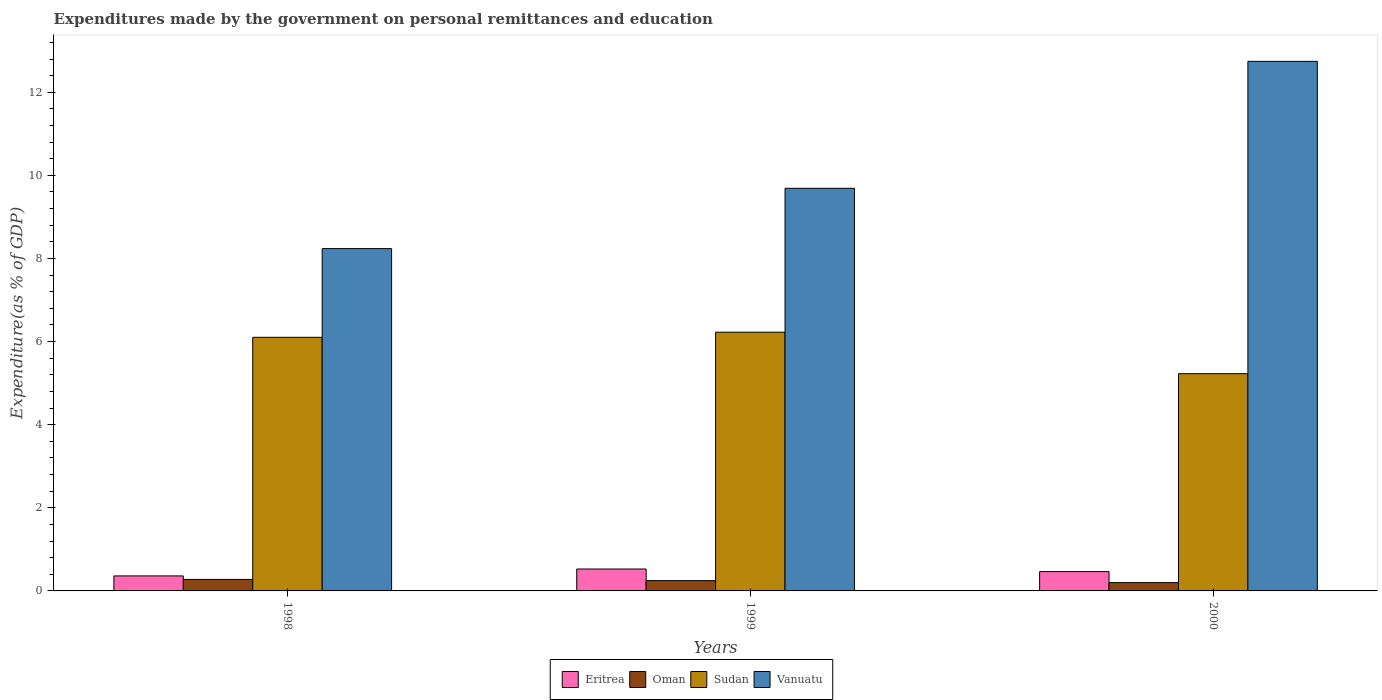How many different coloured bars are there?
Give a very brief answer. 4. Are the number of bars per tick equal to the number of legend labels?
Provide a short and direct response. Yes. Are the number of bars on each tick of the X-axis equal?
Provide a succinct answer. Yes. How many bars are there on the 2nd tick from the left?
Ensure brevity in your answer.  4. What is the label of the 2nd group of bars from the left?
Give a very brief answer. 1999. What is the expenditures made by the government on personal remittances and education in Vanuatu in 1999?
Your answer should be compact. 9.69. Across all years, what is the maximum expenditures made by the government on personal remittances and education in Oman?
Your response must be concise. 0.28. Across all years, what is the minimum expenditures made by the government on personal remittances and education in Oman?
Give a very brief answer. 0.2. In which year was the expenditures made by the government on personal remittances and education in Oman minimum?
Offer a very short reply. 2000. What is the total expenditures made by the government on personal remittances and education in Vanuatu in the graph?
Provide a short and direct response. 30.67. What is the difference between the expenditures made by the government on personal remittances and education in Oman in 1998 and that in 1999?
Ensure brevity in your answer.  0.03. What is the difference between the expenditures made by the government on personal remittances and education in Eritrea in 2000 and the expenditures made by the government on personal remittances and education in Oman in 1999?
Make the answer very short. 0.22. What is the average expenditures made by the government on personal remittances and education in Eritrea per year?
Your answer should be very brief. 0.45. In the year 1998, what is the difference between the expenditures made by the government on personal remittances and education in Eritrea and expenditures made by the government on personal remittances and education in Sudan?
Keep it short and to the point. -5.74. In how many years, is the expenditures made by the government on personal remittances and education in Eritrea greater than 8.4 %?
Provide a short and direct response. 0. What is the ratio of the expenditures made by the government on personal remittances and education in Vanuatu in 1998 to that in 2000?
Offer a very short reply. 0.65. Is the expenditures made by the government on personal remittances and education in Sudan in 1998 less than that in 2000?
Your answer should be very brief. No. Is the difference between the expenditures made by the government on personal remittances and education in Eritrea in 1998 and 2000 greater than the difference between the expenditures made by the government on personal remittances and education in Sudan in 1998 and 2000?
Make the answer very short. No. What is the difference between the highest and the second highest expenditures made by the government on personal remittances and education in Vanuatu?
Ensure brevity in your answer.  3.05. What is the difference between the highest and the lowest expenditures made by the government on personal remittances and education in Oman?
Keep it short and to the point. 0.08. In how many years, is the expenditures made by the government on personal remittances and education in Sudan greater than the average expenditures made by the government on personal remittances and education in Sudan taken over all years?
Your response must be concise. 2. Is the sum of the expenditures made by the government on personal remittances and education in Oman in 1999 and 2000 greater than the maximum expenditures made by the government on personal remittances and education in Eritrea across all years?
Your response must be concise. No. Is it the case that in every year, the sum of the expenditures made by the government on personal remittances and education in Sudan and expenditures made by the government on personal remittances and education in Oman is greater than the sum of expenditures made by the government on personal remittances and education in Vanuatu and expenditures made by the government on personal remittances and education in Eritrea?
Give a very brief answer. No. What does the 1st bar from the left in 1999 represents?
Provide a succinct answer. Eritrea. What does the 4th bar from the right in 1999 represents?
Give a very brief answer. Eritrea. Is it the case that in every year, the sum of the expenditures made by the government on personal remittances and education in Vanuatu and expenditures made by the government on personal remittances and education in Sudan is greater than the expenditures made by the government on personal remittances and education in Eritrea?
Offer a terse response. Yes. Are all the bars in the graph horizontal?
Ensure brevity in your answer.  No. How many years are there in the graph?
Provide a short and direct response. 3. Are the values on the major ticks of Y-axis written in scientific E-notation?
Your response must be concise. No. Where does the legend appear in the graph?
Offer a terse response. Bottom center. How many legend labels are there?
Keep it short and to the point. 4. How are the legend labels stacked?
Provide a succinct answer. Horizontal. What is the title of the graph?
Keep it short and to the point. Expenditures made by the government on personal remittances and education. Does "Bahrain" appear as one of the legend labels in the graph?
Your answer should be very brief. No. What is the label or title of the X-axis?
Provide a short and direct response. Years. What is the label or title of the Y-axis?
Offer a terse response. Expenditure(as % of GDP). What is the Expenditure(as % of GDP) in Eritrea in 1998?
Make the answer very short. 0.36. What is the Expenditure(as % of GDP) of Oman in 1998?
Your answer should be very brief. 0.28. What is the Expenditure(as % of GDP) of Sudan in 1998?
Give a very brief answer. 6.1. What is the Expenditure(as % of GDP) of Vanuatu in 1998?
Ensure brevity in your answer.  8.24. What is the Expenditure(as % of GDP) in Eritrea in 1999?
Your answer should be compact. 0.53. What is the Expenditure(as % of GDP) of Oman in 1999?
Offer a very short reply. 0.25. What is the Expenditure(as % of GDP) of Sudan in 1999?
Make the answer very short. 6.23. What is the Expenditure(as % of GDP) in Vanuatu in 1999?
Your answer should be compact. 9.69. What is the Expenditure(as % of GDP) in Eritrea in 2000?
Your answer should be compact. 0.47. What is the Expenditure(as % of GDP) of Oman in 2000?
Offer a terse response. 0.2. What is the Expenditure(as % of GDP) of Sudan in 2000?
Provide a short and direct response. 5.23. What is the Expenditure(as % of GDP) of Vanuatu in 2000?
Your answer should be compact. 12.74. Across all years, what is the maximum Expenditure(as % of GDP) of Eritrea?
Your response must be concise. 0.53. Across all years, what is the maximum Expenditure(as % of GDP) in Oman?
Provide a short and direct response. 0.28. Across all years, what is the maximum Expenditure(as % of GDP) in Sudan?
Make the answer very short. 6.23. Across all years, what is the maximum Expenditure(as % of GDP) in Vanuatu?
Your response must be concise. 12.74. Across all years, what is the minimum Expenditure(as % of GDP) in Eritrea?
Give a very brief answer. 0.36. Across all years, what is the minimum Expenditure(as % of GDP) in Oman?
Offer a very short reply. 0.2. Across all years, what is the minimum Expenditure(as % of GDP) in Sudan?
Your response must be concise. 5.23. Across all years, what is the minimum Expenditure(as % of GDP) of Vanuatu?
Your answer should be compact. 8.24. What is the total Expenditure(as % of GDP) in Eritrea in the graph?
Provide a succinct answer. 1.35. What is the total Expenditure(as % of GDP) of Oman in the graph?
Provide a succinct answer. 0.73. What is the total Expenditure(as % of GDP) of Sudan in the graph?
Ensure brevity in your answer.  17.56. What is the total Expenditure(as % of GDP) of Vanuatu in the graph?
Keep it short and to the point. 30.67. What is the difference between the Expenditure(as % of GDP) of Eritrea in 1998 and that in 1999?
Keep it short and to the point. -0.17. What is the difference between the Expenditure(as % of GDP) of Oman in 1998 and that in 1999?
Give a very brief answer. 0.03. What is the difference between the Expenditure(as % of GDP) in Sudan in 1998 and that in 1999?
Ensure brevity in your answer.  -0.12. What is the difference between the Expenditure(as % of GDP) in Vanuatu in 1998 and that in 1999?
Keep it short and to the point. -1.45. What is the difference between the Expenditure(as % of GDP) of Eritrea in 1998 and that in 2000?
Your answer should be compact. -0.1. What is the difference between the Expenditure(as % of GDP) in Oman in 1998 and that in 2000?
Provide a succinct answer. 0.08. What is the difference between the Expenditure(as % of GDP) of Sudan in 1998 and that in 2000?
Provide a succinct answer. 0.88. What is the difference between the Expenditure(as % of GDP) in Vanuatu in 1998 and that in 2000?
Make the answer very short. -4.51. What is the difference between the Expenditure(as % of GDP) in Eritrea in 1999 and that in 2000?
Ensure brevity in your answer.  0.06. What is the difference between the Expenditure(as % of GDP) in Oman in 1999 and that in 2000?
Offer a very short reply. 0.05. What is the difference between the Expenditure(as % of GDP) of Sudan in 1999 and that in 2000?
Your answer should be compact. 1. What is the difference between the Expenditure(as % of GDP) of Vanuatu in 1999 and that in 2000?
Give a very brief answer. -3.05. What is the difference between the Expenditure(as % of GDP) of Eritrea in 1998 and the Expenditure(as % of GDP) of Oman in 1999?
Keep it short and to the point. 0.11. What is the difference between the Expenditure(as % of GDP) of Eritrea in 1998 and the Expenditure(as % of GDP) of Sudan in 1999?
Keep it short and to the point. -5.87. What is the difference between the Expenditure(as % of GDP) in Eritrea in 1998 and the Expenditure(as % of GDP) in Vanuatu in 1999?
Provide a succinct answer. -9.33. What is the difference between the Expenditure(as % of GDP) of Oman in 1998 and the Expenditure(as % of GDP) of Sudan in 1999?
Your answer should be compact. -5.95. What is the difference between the Expenditure(as % of GDP) of Oman in 1998 and the Expenditure(as % of GDP) of Vanuatu in 1999?
Provide a succinct answer. -9.41. What is the difference between the Expenditure(as % of GDP) of Sudan in 1998 and the Expenditure(as % of GDP) of Vanuatu in 1999?
Your answer should be compact. -3.59. What is the difference between the Expenditure(as % of GDP) of Eritrea in 1998 and the Expenditure(as % of GDP) of Oman in 2000?
Provide a short and direct response. 0.16. What is the difference between the Expenditure(as % of GDP) in Eritrea in 1998 and the Expenditure(as % of GDP) in Sudan in 2000?
Offer a terse response. -4.87. What is the difference between the Expenditure(as % of GDP) of Eritrea in 1998 and the Expenditure(as % of GDP) of Vanuatu in 2000?
Make the answer very short. -12.38. What is the difference between the Expenditure(as % of GDP) of Oman in 1998 and the Expenditure(as % of GDP) of Sudan in 2000?
Your answer should be compact. -4.95. What is the difference between the Expenditure(as % of GDP) of Oman in 1998 and the Expenditure(as % of GDP) of Vanuatu in 2000?
Make the answer very short. -12.47. What is the difference between the Expenditure(as % of GDP) in Sudan in 1998 and the Expenditure(as % of GDP) in Vanuatu in 2000?
Provide a short and direct response. -6.64. What is the difference between the Expenditure(as % of GDP) of Eritrea in 1999 and the Expenditure(as % of GDP) of Oman in 2000?
Provide a short and direct response. 0.33. What is the difference between the Expenditure(as % of GDP) in Eritrea in 1999 and the Expenditure(as % of GDP) in Sudan in 2000?
Provide a short and direct response. -4.7. What is the difference between the Expenditure(as % of GDP) of Eritrea in 1999 and the Expenditure(as % of GDP) of Vanuatu in 2000?
Your answer should be very brief. -12.22. What is the difference between the Expenditure(as % of GDP) in Oman in 1999 and the Expenditure(as % of GDP) in Sudan in 2000?
Give a very brief answer. -4.98. What is the difference between the Expenditure(as % of GDP) of Oman in 1999 and the Expenditure(as % of GDP) of Vanuatu in 2000?
Make the answer very short. -12.5. What is the difference between the Expenditure(as % of GDP) of Sudan in 1999 and the Expenditure(as % of GDP) of Vanuatu in 2000?
Provide a short and direct response. -6.52. What is the average Expenditure(as % of GDP) in Eritrea per year?
Your response must be concise. 0.45. What is the average Expenditure(as % of GDP) of Oman per year?
Offer a terse response. 0.24. What is the average Expenditure(as % of GDP) in Sudan per year?
Your answer should be very brief. 5.85. What is the average Expenditure(as % of GDP) in Vanuatu per year?
Your response must be concise. 10.22. In the year 1998, what is the difference between the Expenditure(as % of GDP) of Eritrea and Expenditure(as % of GDP) of Oman?
Provide a succinct answer. 0.08. In the year 1998, what is the difference between the Expenditure(as % of GDP) in Eritrea and Expenditure(as % of GDP) in Sudan?
Keep it short and to the point. -5.74. In the year 1998, what is the difference between the Expenditure(as % of GDP) of Eritrea and Expenditure(as % of GDP) of Vanuatu?
Ensure brevity in your answer.  -7.88. In the year 1998, what is the difference between the Expenditure(as % of GDP) in Oman and Expenditure(as % of GDP) in Sudan?
Your response must be concise. -5.83. In the year 1998, what is the difference between the Expenditure(as % of GDP) of Oman and Expenditure(as % of GDP) of Vanuatu?
Ensure brevity in your answer.  -7.96. In the year 1998, what is the difference between the Expenditure(as % of GDP) of Sudan and Expenditure(as % of GDP) of Vanuatu?
Ensure brevity in your answer.  -2.13. In the year 1999, what is the difference between the Expenditure(as % of GDP) in Eritrea and Expenditure(as % of GDP) in Oman?
Your answer should be compact. 0.28. In the year 1999, what is the difference between the Expenditure(as % of GDP) in Eritrea and Expenditure(as % of GDP) in Sudan?
Your answer should be very brief. -5.7. In the year 1999, what is the difference between the Expenditure(as % of GDP) of Eritrea and Expenditure(as % of GDP) of Vanuatu?
Make the answer very short. -9.16. In the year 1999, what is the difference between the Expenditure(as % of GDP) in Oman and Expenditure(as % of GDP) in Sudan?
Offer a very short reply. -5.98. In the year 1999, what is the difference between the Expenditure(as % of GDP) in Oman and Expenditure(as % of GDP) in Vanuatu?
Your response must be concise. -9.44. In the year 1999, what is the difference between the Expenditure(as % of GDP) of Sudan and Expenditure(as % of GDP) of Vanuatu?
Ensure brevity in your answer.  -3.46. In the year 2000, what is the difference between the Expenditure(as % of GDP) in Eritrea and Expenditure(as % of GDP) in Oman?
Offer a terse response. 0.27. In the year 2000, what is the difference between the Expenditure(as % of GDP) of Eritrea and Expenditure(as % of GDP) of Sudan?
Make the answer very short. -4.76. In the year 2000, what is the difference between the Expenditure(as % of GDP) of Eritrea and Expenditure(as % of GDP) of Vanuatu?
Offer a terse response. -12.28. In the year 2000, what is the difference between the Expenditure(as % of GDP) of Oman and Expenditure(as % of GDP) of Sudan?
Provide a short and direct response. -5.03. In the year 2000, what is the difference between the Expenditure(as % of GDP) of Oman and Expenditure(as % of GDP) of Vanuatu?
Keep it short and to the point. -12.54. In the year 2000, what is the difference between the Expenditure(as % of GDP) of Sudan and Expenditure(as % of GDP) of Vanuatu?
Your response must be concise. -7.52. What is the ratio of the Expenditure(as % of GDP) of Eritrea in 1998 to that in 1999?
Offer a very short reply. 0.68. What is the ratio of the Expenditure(as % of GDP) in Oman in 1998 to that in 1999?
Offer a terse response. 1.12. What is the ratio of the Expenditure(as % of GDP) of Sudan in 1998 to that in 1999?
Make the answer very short. 0.98. What is the ratio of the Expenditure(as % of GDP) of Vanuatu in 1998 to that in 1999?
Offer a very short reply. 0.85. What is the ratio of the Expenditure(as % of GDP) in Eritrea in 1998 to that in 2000?
Keep it short and to the point. 0.78. What is the ratio of the Expenditure(as % of GDP) in Oman in 1998 to that in 2000?
Ensure brevity in your answer.  1.38. What is the ratio of the Expenditure(as % of GDP) in Sudan in 1998 to that in 2000?
Offer a terse response. 1.17. What is the ratio of the Expenditure(as % of GDP) of Vanuatu in 1998 to that in 2000?
Offer a terse response. 0.65. What is the ratio of the Expenditure(as % of GDP) in Eritrea in 1999 to that in 2000?
Ensure brevity in your answer.  1.13. What is the ratio of the Expenditure(as % of GDP) of Oman in 1999 to that in 2000?
Your answer should be very brief. 1.24. What is the ratio of the Expenditure(as % of GDP) of Sudan in 1999 to that in 2000?
Give a very brief answer. 1.19. What is the ratio of the Expenditure(as % of GDP) of Vanuatu in 1999 to that in 2000?
Offer a very short reply. 0.76. What is the difference between the highest and the second highest Expenditure(as % of GDP) of Eritrea?
Provide a short and direct response. 0.06. What is the difference between the highest and the second highest Expenditure(as % of GDP) of Oman?
Offer a very short reply. 0.03. What is the difference between the highest and the second highest Expenditure(as % of GDP) of Sudan?
Offer a very short reply. 0.12. What is the difference between the highest and the second highest Expenditure(as % of GDP) of Vanuatu?
Offer a very short reply. 3.05. What is the difference between the highest and the lowest Expenditure(as % of GDP) in Eritrea?
Offer a terse response. 0.17. What is the difference between the highest and the lowest Expenditure(as % of GDP) of Oman?
Provide a short and direct response. 0.08. What is the difference between the highest and the lowest Expenditure(as % of GDP) of Sudan?
Make the answer very short. 1. What is the difference between the highest and the lowest Expenditure(as % of GDP) of Vanuatu?
Keep it short and to the point. 4.51. 